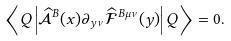Convert formula to latex. <formula><loc_0><loc_0><loc_500><loc_500>\left \langle Q \left | \widehat { \mathcal { A } } ^ { B } ( x ) \partial _ { y \nu } \widehat { \mathcal { F } } ^ { B \mu \nu } ( y ) \right | Q \right \rangle = 0 .</formula> 